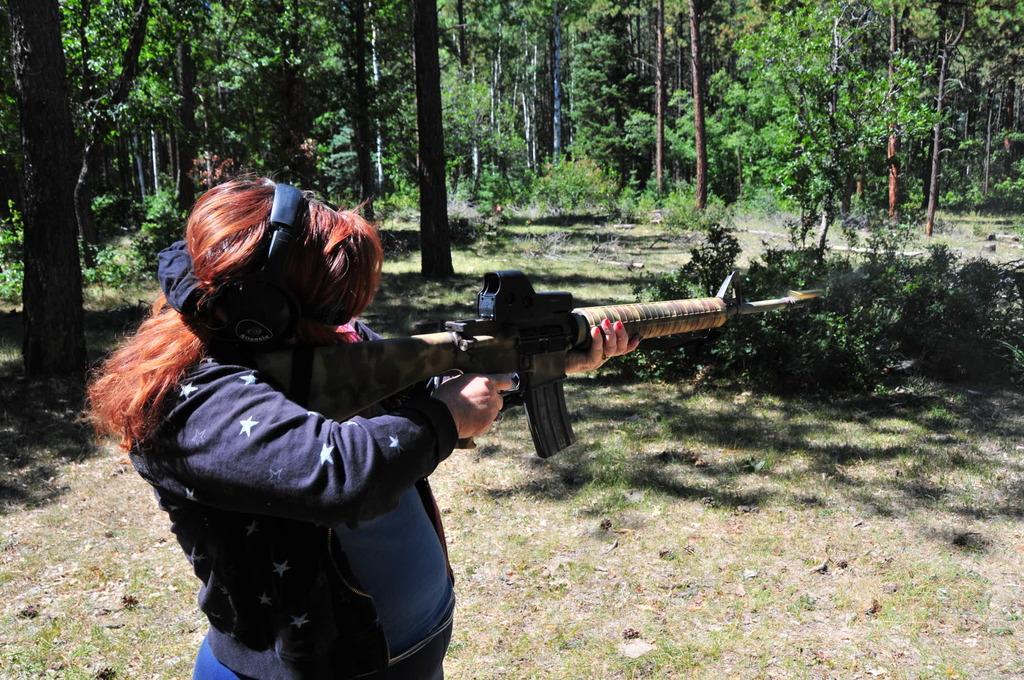Describe this image in one or two sentences. In the background we can see the trees. In this picture we can see the plants. At the bottom portion of the picture we can see the dried leaves and grass. We can see a woman holding a gun in her hands. She wore headphones. 